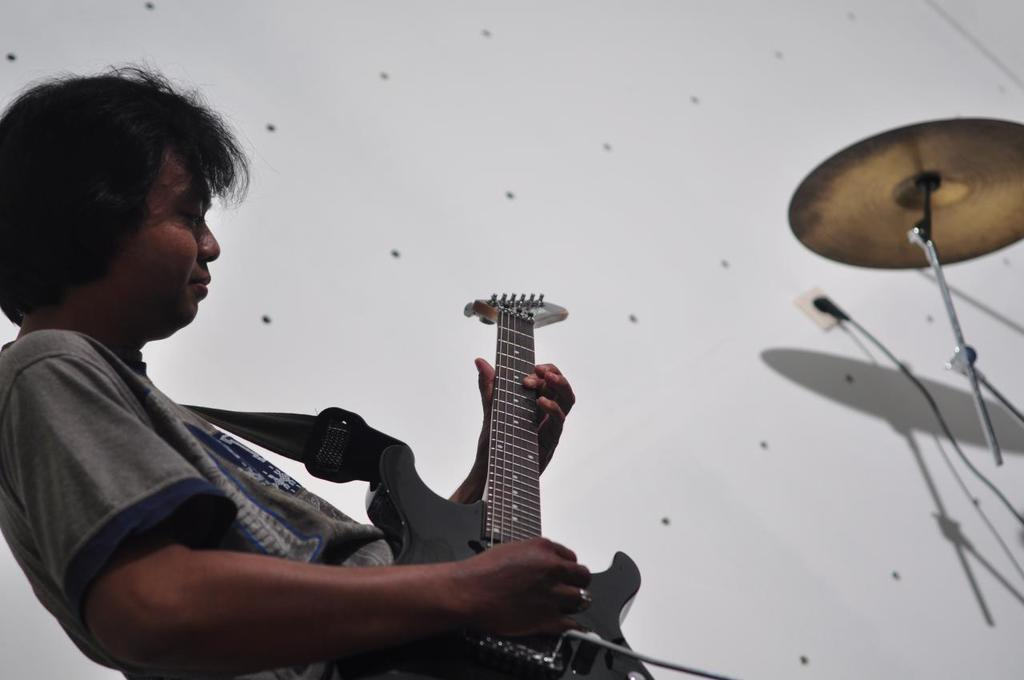What is the man in the image doing? The man is playing a guitar. What type of object is the man using to create music? The guitar is a musical instrument that the man is using. What can be seen in the background of the image? There is a wall in the image. How many cats are sitting on the furniture in the image? There are no cats or furniture present in the image. 